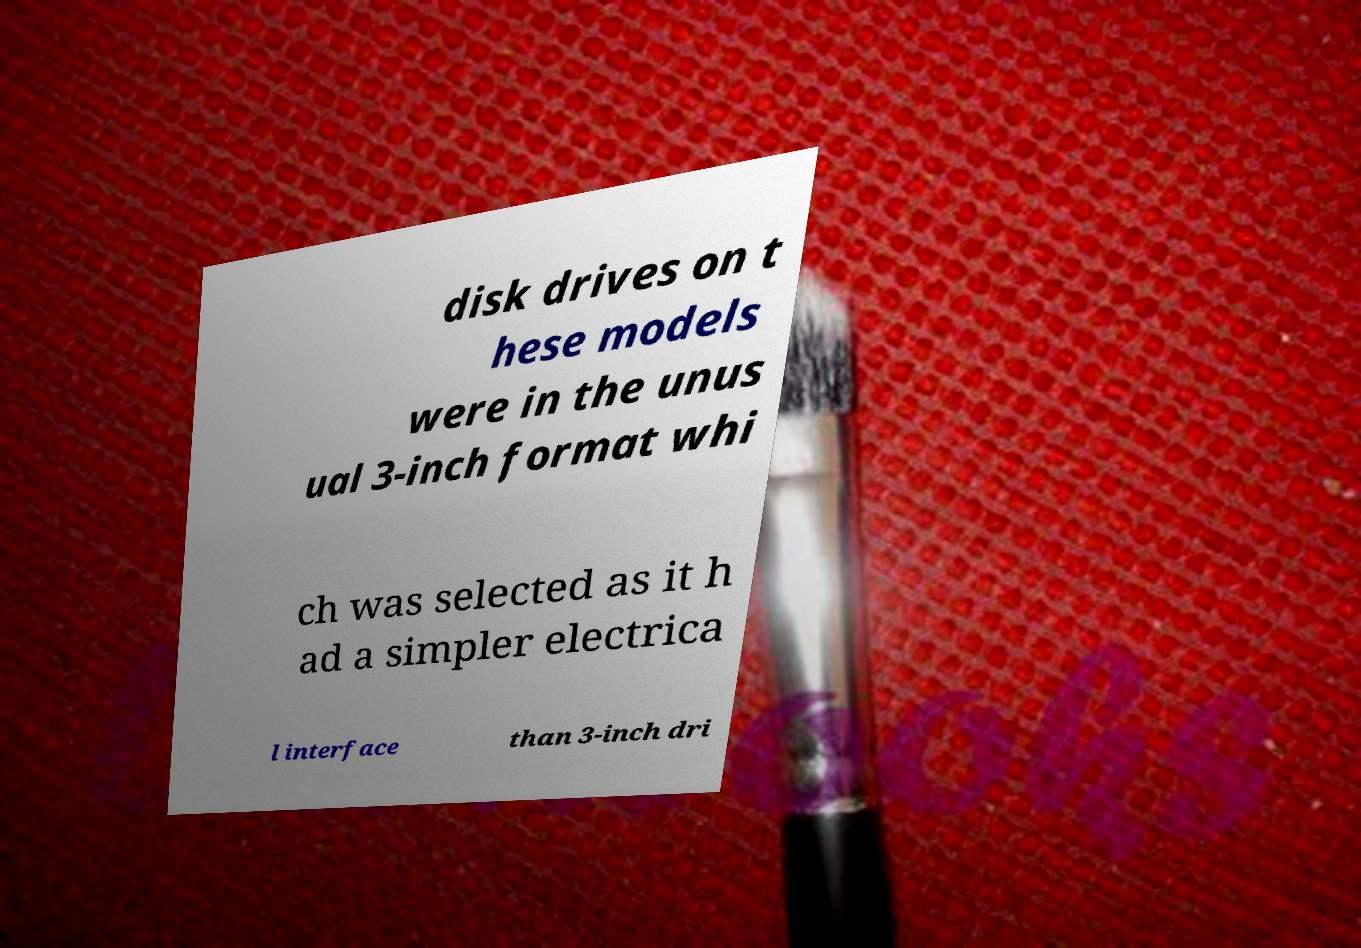Could you assist in decoding the text presented in this image and type it out clearly? disk drives on t hese models were in the unus ual 3-inch format whi ch was selected as it h ad a simpler electrica l interface than 3-inch dri 